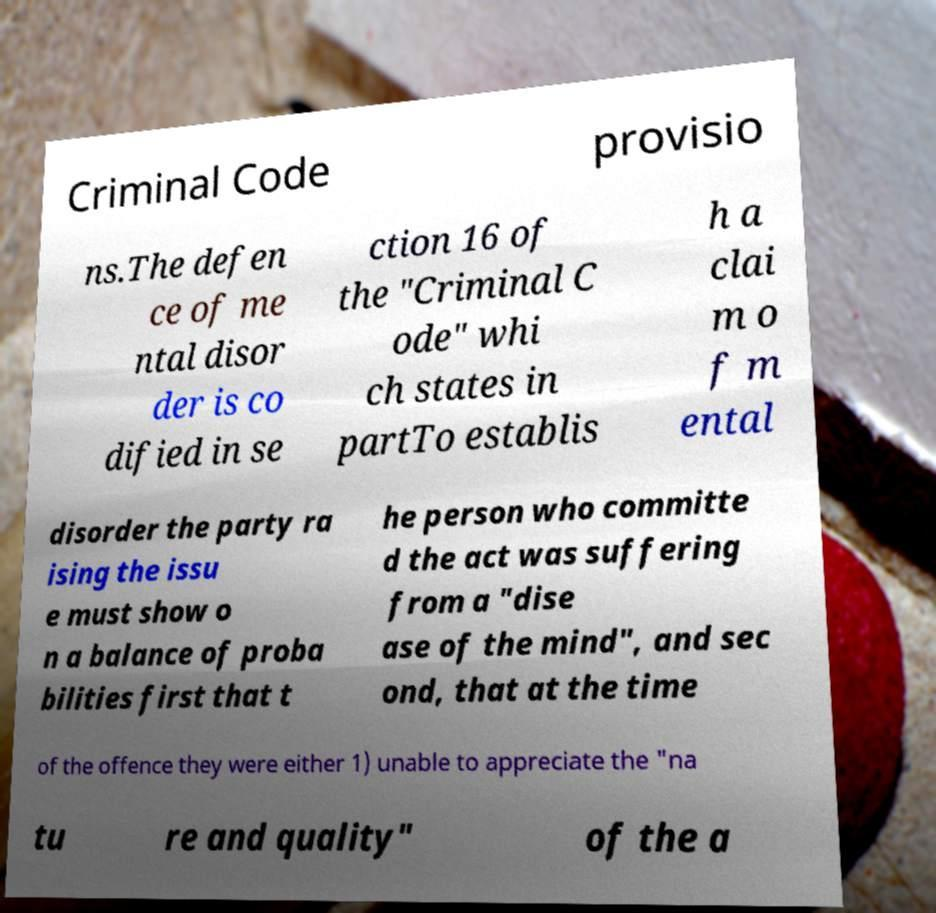Could you extract and type out the text from this image? Criminal Code provisio ns.The defen ce of me ntal disor der is co dified in se ction 16 of the "Criminal C ode" whi ch states in partTo establis h a clai m o f m ental disorder the party ra ising the issu e must show o n a balance of proba bilities first that t he person who committe d the act was suffering from a "dise ase of the mind", and sec ond, that at the time of the offence they were either 1) unable to appreciate the "na tu re and quality" of the a 